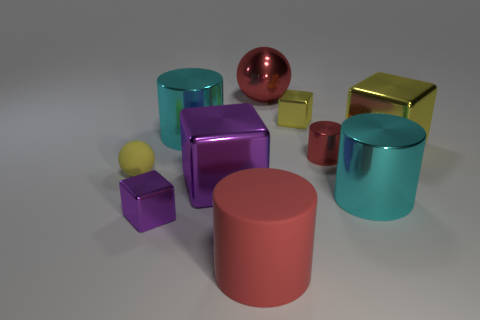Subtract all tiny red metal cylinders. How many cylinders are left? 3 Subtract all yellow cylinders. How many yellow blocks are left? 2 Subtract 1 cylinders. How many cylinders are left? 3 Subtract all yellow cylinders. Subtract all red cubes. How many cylinders are left? 4 Subtract 0 cyan balls. How many objects are left? 10 Subtract all cylinders. How many objects are left? 6 Subtract all small purple metal things. Subtract all metal cubes. How many objects are left? 5 Add 6 tiny red metal cylinders. How many tiny red metal cylinders are left? 7 Add 4 big yellow rubber cylinders. How many big yellow rubber cylinders exist? 4 